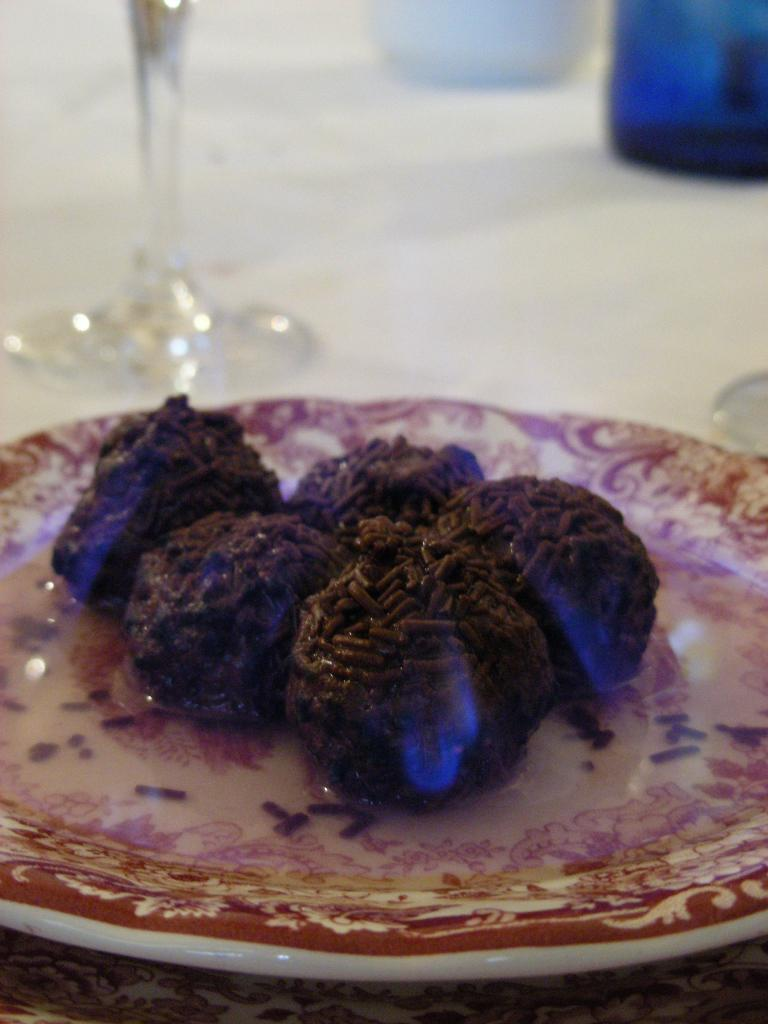What piece of furniture is present in the image? There is a table in the image. What is placed on the table? There is a plate on the table. What is on the plate? The plate contains a food item. What else is on the table besides the plate? There is a glass on the table. How many clocks are visible on the table in the image? There are no clocks visible on the table in the image. What type of flesh is present on the plate in the image? There is no flesh present on the plate in the image; it contains a food item, but the specific type of food is not mentioned. 